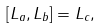<formula> <loc_0><loc_0><loc_500><loc_500>[ L _ { a } , L _ { b } ] = L _ { c } ,</formula> 